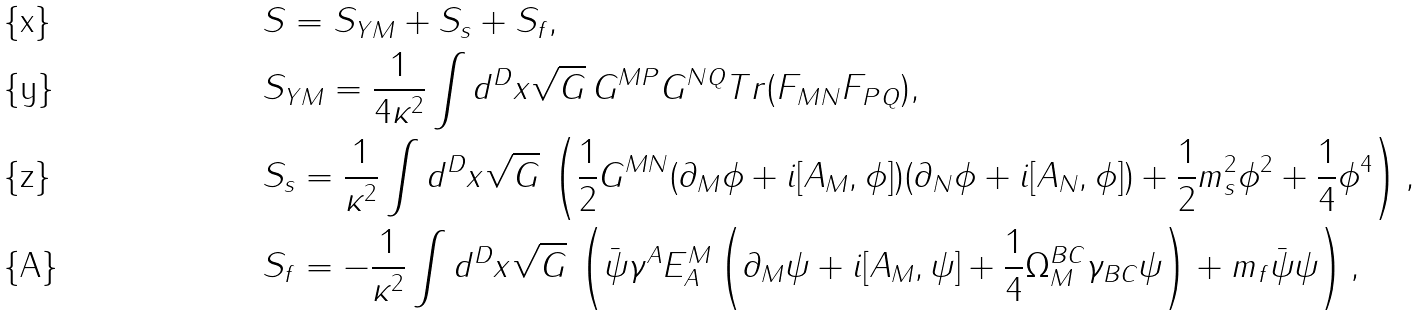Convert formula to latex. <formula><loc_0><loc_0><loc_500><loc_500>& S = S _ { Y M } + S _ { s } + S _ { f } , \\ & S _ { Y M } = \frac { 1 } { 4 \kappa ^ { 2 } } \int d ^ { D } x \sqrt { G } \, G ^ { M P } G ^ { N Q } T r ( F _ { M N } F _ { P Q } ) , \\ & S _ { s } = \frac { 1 } { \kappa ^ { 2 } } \int d ^ { D } x \sqrt { G } \, \left ( \frac { 1 } { 2 } G ^ { M N } ( \partial _ { M } \phi + i [ A _ { M } , \phi ] ) ( \partial _ { N } \phi + i [ A _ { N } , \phi ] ) + \frac { 1 } { 2 } m _ { s } ^ { 2 } \phi ^ { 2 } + \frac { 1 } { 4 } \phi ^ { 4 } \right ) , \\ & S _ { f } = - \frac { 1 } { \kappa ^ { 2 } } \int d ^ { D } x \sqrt { G } \, \left ( \bar { \psi } \gamma ^ { A } E ^ { M } _ { A } \left ( \partial _ { M } \psi + i [ A _ { M } , \psi ] + \frac { 1 } { 4 } \Omega _ { M } ^ { B C } \gamma _ { B C } \psi \right ) + m _ { f } \bar { \psi } \psi \right ) ,</formula> 